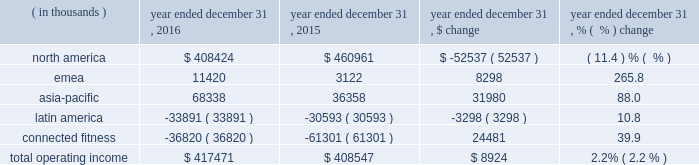Operating income ( loss ) by segment is summarized below: .
The increase in total operating income was driven by the following : 2022 operating income in our north america operating segment decreased $ 52.5 million to $ 408.4 million in 2016 from $ 461.0 million in 2015 primarily due to decreases in gross margin discussed above in the consolidated results of operations and $ 17.0 million in expenses related to the liquidation of the sports authority , comprised of $ 15.2 million in bad debt expense and $ 1.8 million of in-store fixture impairment .
In addition , this decrease reflects the movement of $ 11.1 million in expenses resulting from a strategic shift in headcount supporting our global business from our connected fitness operating segment to north america .
This decrease is partially offset by the increases in revenue discussed above in the consolidated results of operations .
2022 operating income in our emea operating segment increased $ 8.3 million to $ 11.4 million in 2016 from $ 3.1 million in 2015 primarily due to sales growth discussed above and reductions in incentive compensation .
This increase was offset by investments in sports marketing and infrastructure for future growth .
2022 operating income in our asia-pacific operating segment increased $ 31.9 million to $ 68.3 million in 2016 from $ 36.4 million in 2015 primarily due to sales growth discussed above and reductions in incentive compensation .
This increase was offset by investments in our direct-to-consumer business and entry into new territories .
2022 operating loss in our latin america operating segment increased $ 3.3 million to $ 33.9 million in 2016 from $ 30.6 million in 2015 primarily due to increased investments to support growth in the region and the economic challenges in brazil during the period .
This increase in operating loss was offset by sales growth discussed above and reductions in incentive compensation .
2022 operating loss in our connected fitness segment decreased $ 24.5 million to $ 36.8 million in 2016 from $ 61.3 million in 2015 primarily driven by sales growth discussed above .
Seasonality historically , we have recognized a majority of our net revenues and a significant portion of our income from operations in the last two quarters of the year , driven primarily by increased sales volume of our products during the fall selling season , including our higher priced cold weather products , along with a larger proportion of higher margin direct to consumer sales .
The level of our working capital generally reflects the seasonality and growth in our business .
We generally expect inventory , accounts payable and certain accrued expenses to be higher in the second and third quarters in preparation for the fall selling season. .
What percentage of operating income was the asia-pacific segment in 2016? 
Computations: (68338 / 417471)
Answer: 0.1637. 